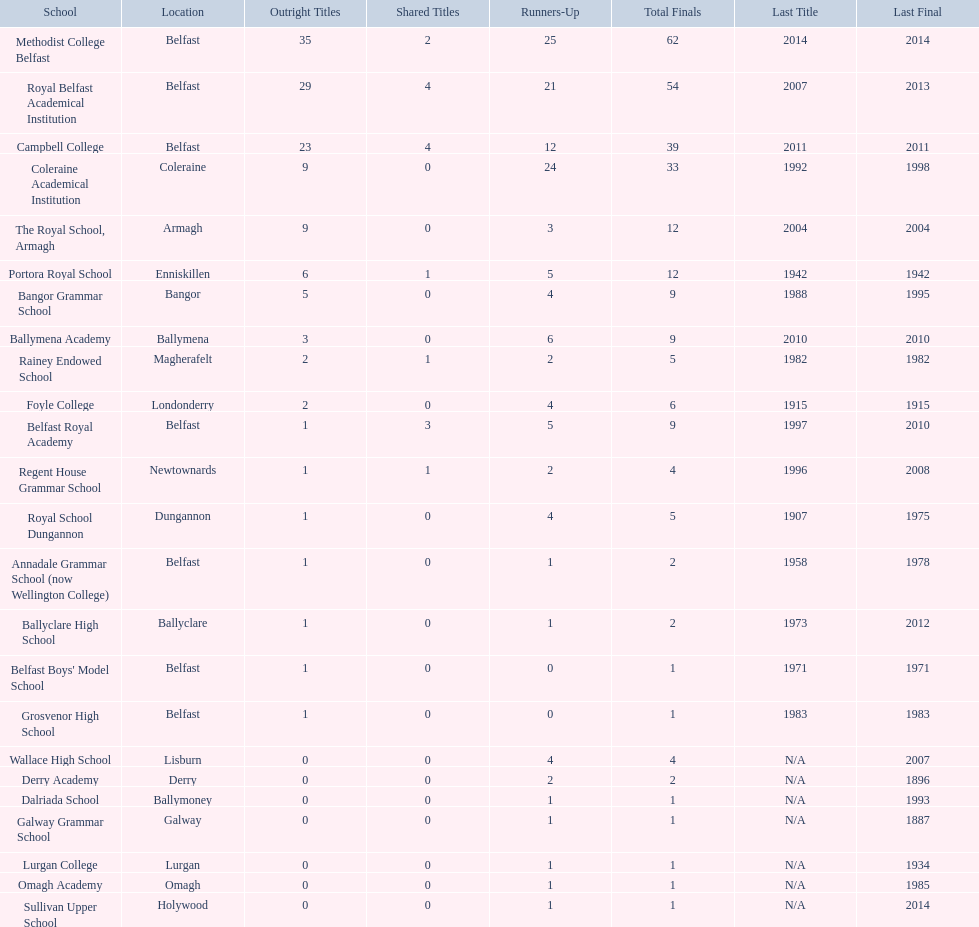What are the names of all the schools? Methodist College Belfast, Royal Belfast Academical Institution, Campbell College, Coleraine Academical Institution, The Royal School, Armagh, Portora Royal School, Bangor Grammar School, Ballymena Academy, Rainey Endowed School, Foyle College, Belfast Royal Academy, Regent House Grammar School, Royal School Dungannon, Annadale Grammar School (now Wellington College), Ballyclare High School, Belfast Boys' Model School, Grosvenor High School, Wallace High School, Derry Academy, Dalriada School, Galway Grammar School, Lurgan College, Omagh Academy, Sullivan Upper School. How many outright titles were won by them? 35, 29, 23, 9, 9, 6, 5, 3, 2, 2, 1, 1, 1, 1, 1, 1, 1, 0, 0, 0, 0, 0, 0, 0. How many outright titles did coleraine academical institution achieve? 9. Which other school has the same number of outright titles as them? The Royal School, Armagh. 